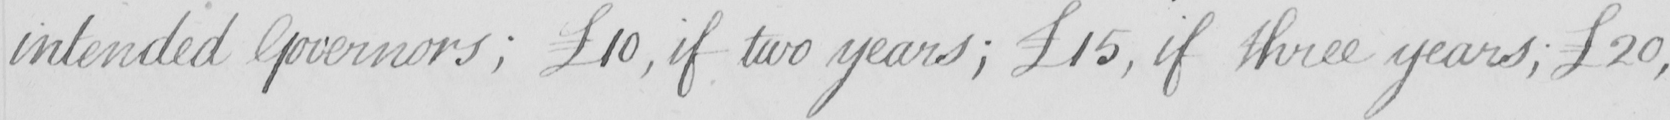Can you read and transcribe this handwriting? intended Governors ;  £10 , if two years ;  £15 , if three years ;  £20 , 